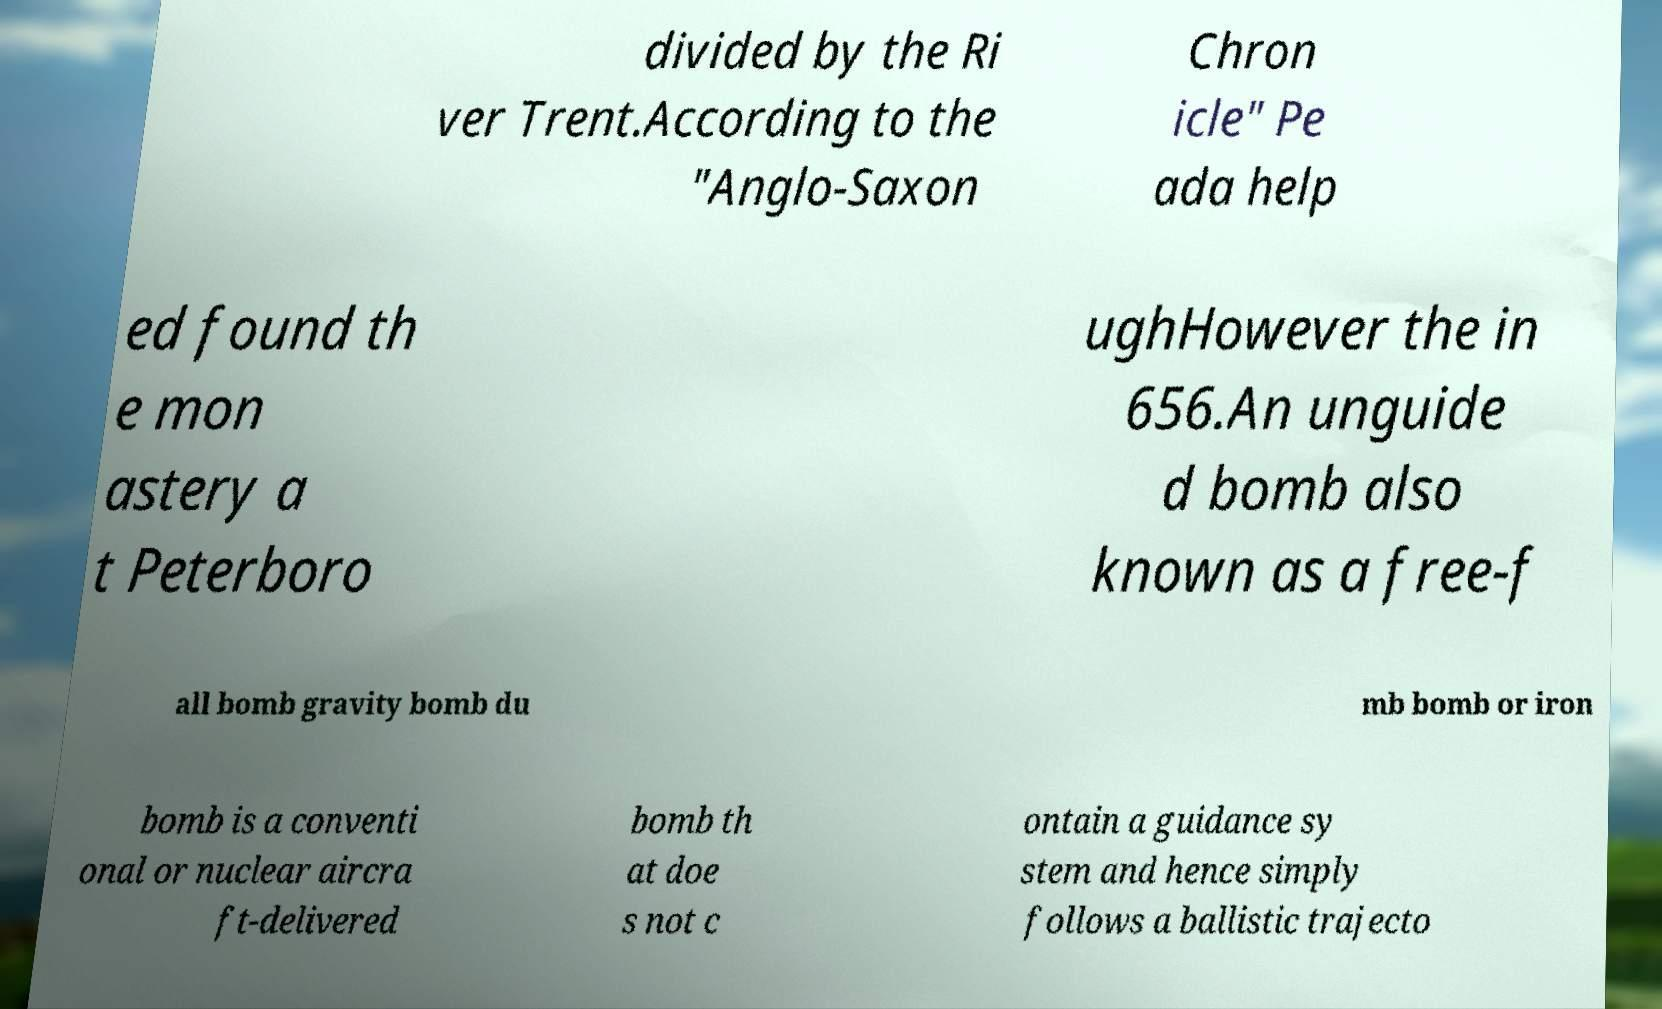Please identify and transcribe the text found in this image. divided by the Ri ver Trent.According to the "Anglo-Saxon Chron icle" Pe ada help ed found th e mon astery a t Peterboro ughHowever the in 656.An unguide d bomb also known as a free-f all bomb gravity bomb du mb bomb or iron bomb is a conventi onal or nuclear aircra ft-delivered bomb th at doe s not c ontain a guidance sy stem and hence simply follows a ballistic trajecto 